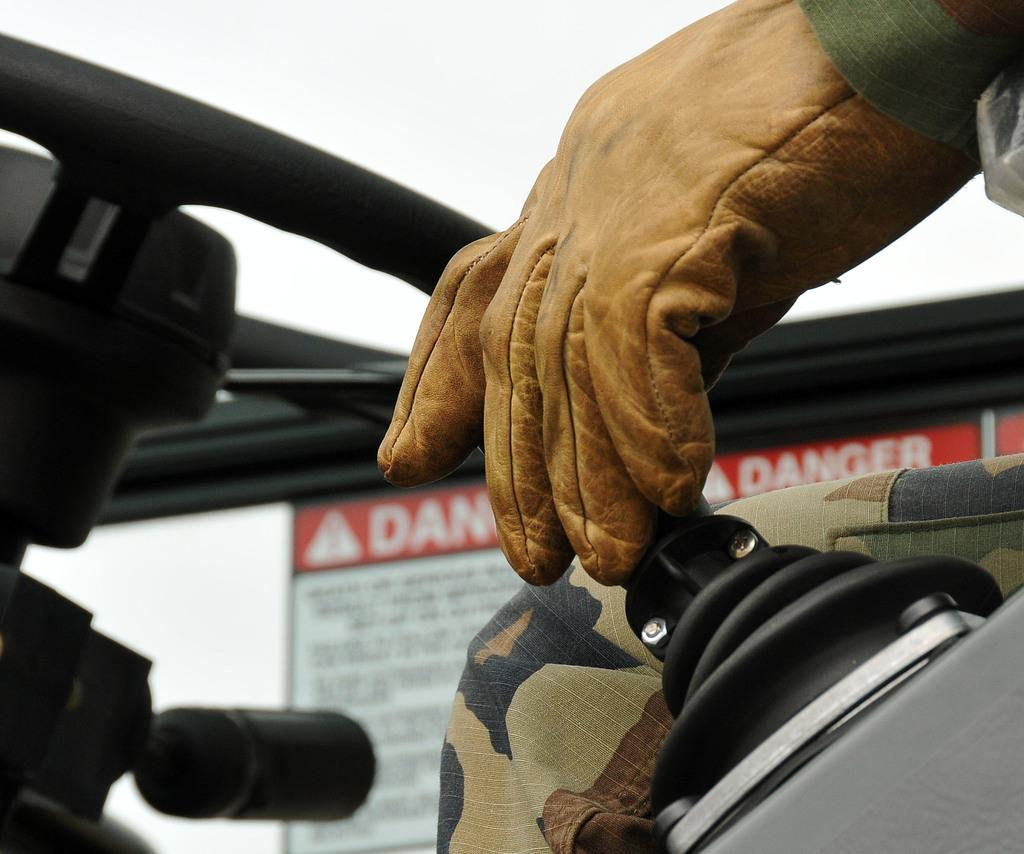What vehicle is present in the image? There is a jeep in the image. Who is inside the jeep? A man is sitting in the jeep. What can be seen in the background of the image? There is a board in the background of the image. What is written on the board? There is text on the board. Can you see any grains of sand on the man's thumb in the image? There is no reference to sand or a thumb in the image, so it is not possible to answer that question. 